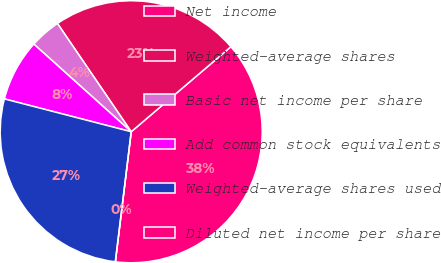Convert chart to OTSL. <chart><loc_0><loc_0><loc_500><loc_500><pie_chart><fcel>Net income<fcel>Weighted-average shares<fcel>Basic net income per share<fcel>Add common stock equivalents<fcel>Weighted-average shares used<fcel>Diluted net income per share<nl><fcel>38.17%<fcel>23.28%<fcel>3.82%<fcel>7.63%<fcel>27.1%<fcel>0.0%<nl></chart> 